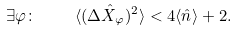Convert formula to latex. <formula><loc_0><loc_0><loc_500><loc_500>\exists \varphi \colon \quad \langle ( \Delta \hat { X } _ { \varphi } ) ^ { 2 } \rangle < 4 \langle \hat { n } \rangle + 2 .</formula> 